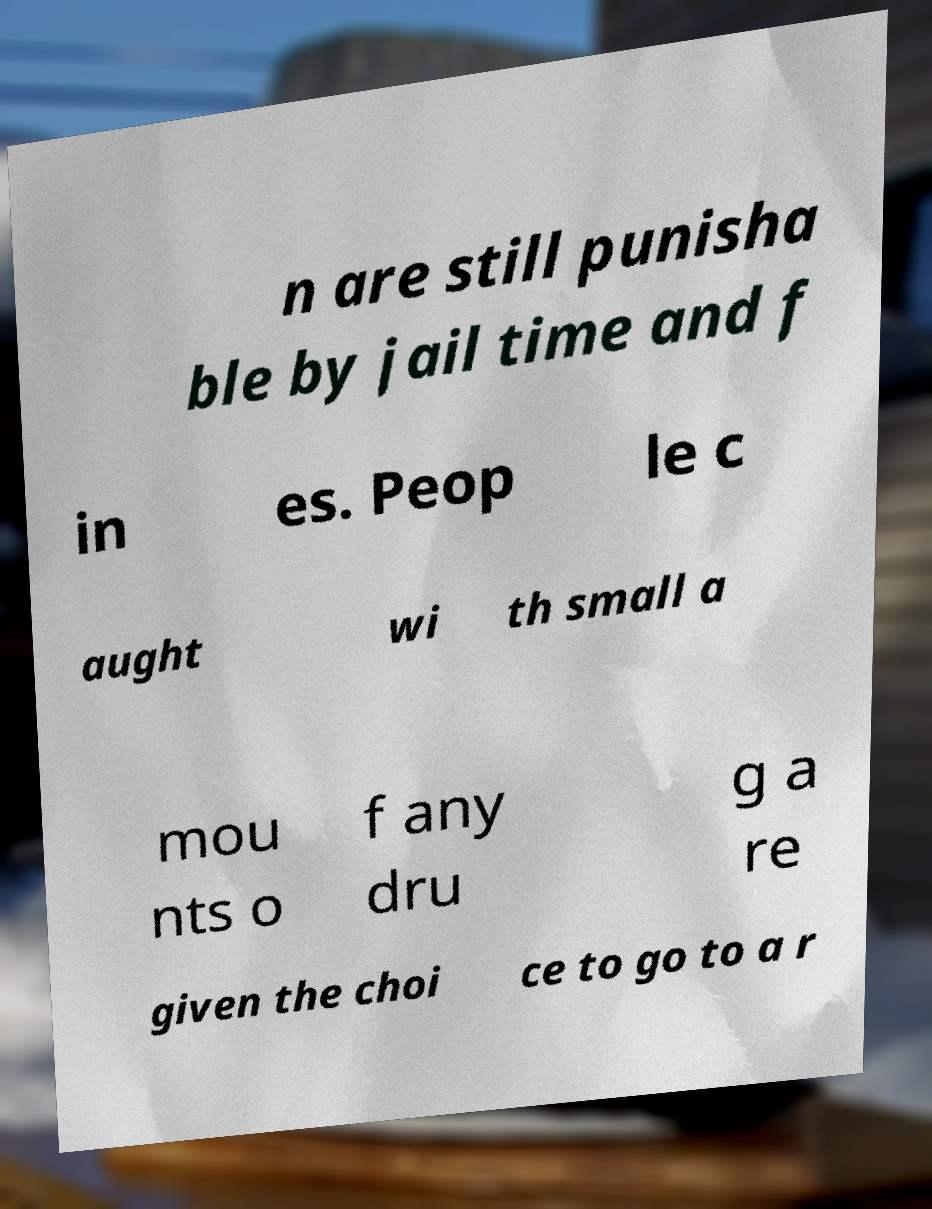Please read and relay the text visible in this image. What does it say? n are still punisha ble by jail time and f in es. Peop le c aught wi th small a mou nts o f any dru g a re given the choi ce to go to a r 